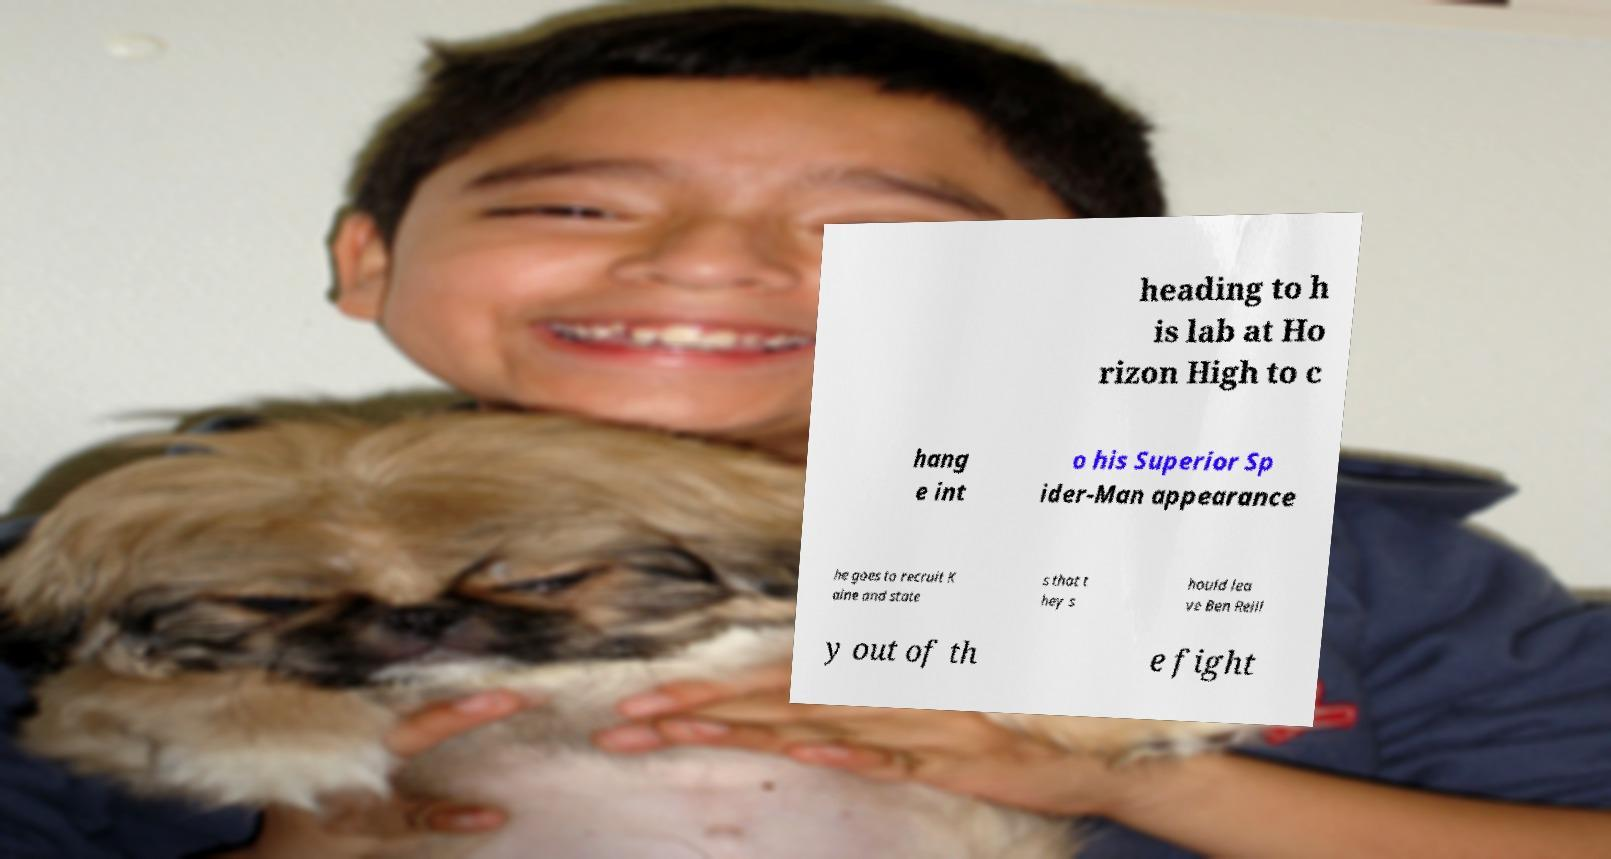Could you extract and type out the text from this image? heading to h is lab at Ho rizon High to c hang e int o his Superior Sp ider-Man appearance he goes to recruit K aine and state s that t hey s hould lea ve Ben Reill y out of th e fight 